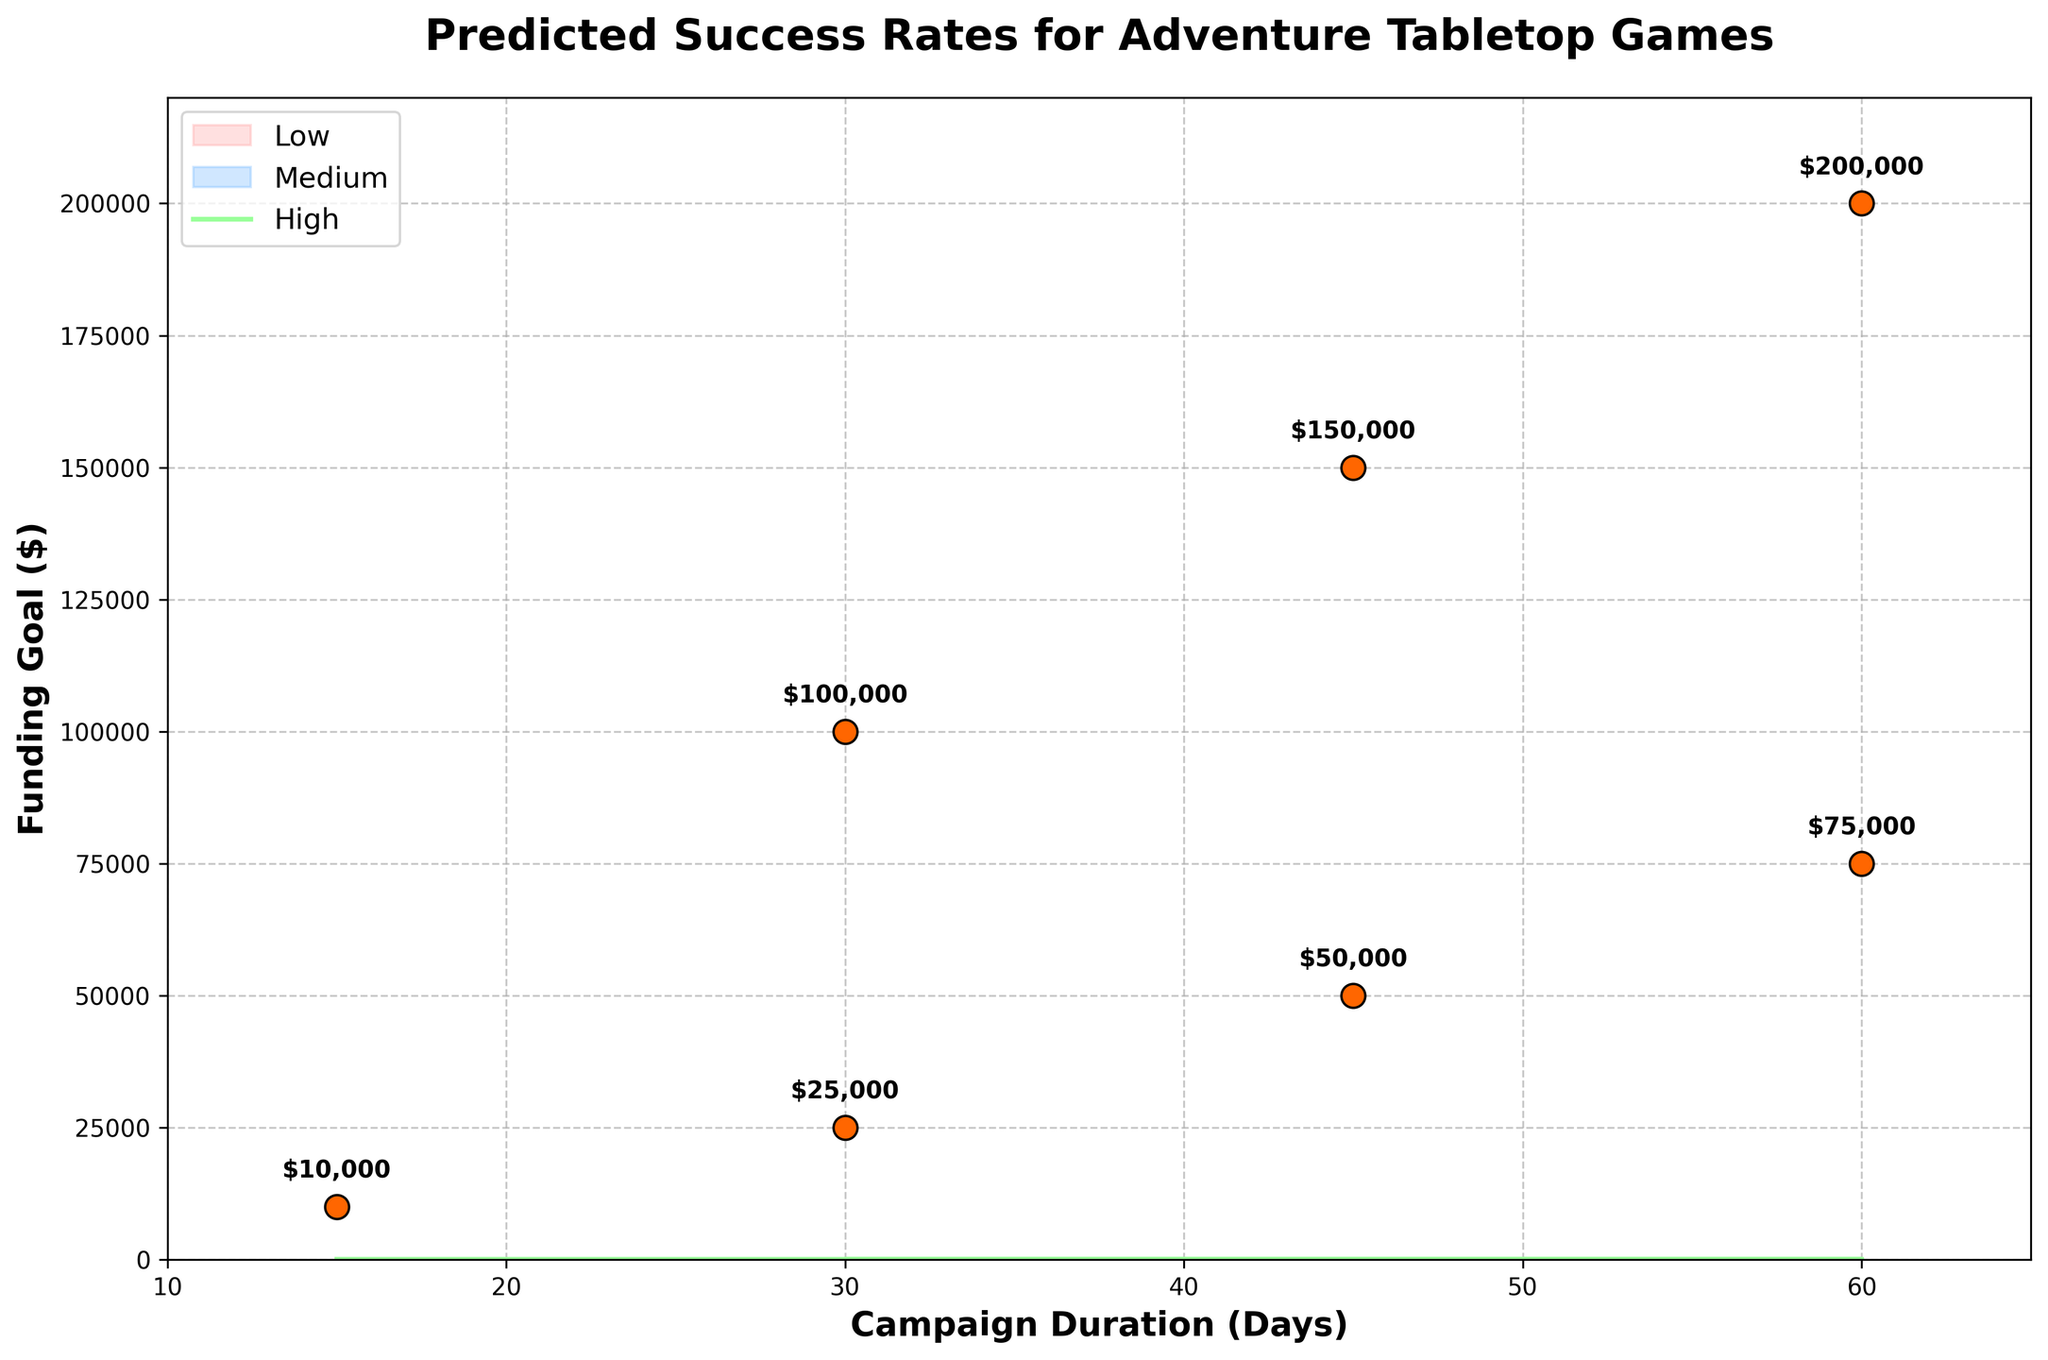What's the title of the figure? The answer can be found by simply looking at the top of the figure.
Answer: Predicted Success Rates for Adventure Tabletop Games What is the campaign duration range shown on the x-axis? The x-axis shows the range of Campaign Duration in days, and by looking at both ends of the x-axis, we can determine the range. The axis starts at 10 and ends at 65.
Answer: 10 to 65 days What color represents the 'Medium Success Rate' area in the fan chart? The Medium Success Rate area is filled with a distinct color that stands out in the legend. By checking the legend, '#66B2FF' or 'Medium' is the relevant color.
Answer: Blue How many data points are plotted as scatter points? Each data point is marked with a scatter point on the chart. By counting the individual points scattered on the plot, we see there are seven.
Answer: 7 What is the funding goal for a 45-day campaign? Look along the x-axis for a campaign duration of 45 days, then check the annotated value nearby the corresponding scatter point. It is clearly indicated as $50,000.
Answer: $50,000 What is the range of predicted success rates for a 45-day campaign with a $50,000 goal? Locate the 45-day point on the x-axis and examine the fan chart bands around this point. The low success rate is 35%, and the high success rate is 65%.
Answer: 35% to 65% What is the greatest funding goal among the campaigns, and what is its corresponding campaign duration? Look for the highest value annotated on the scatter plot which represents the funding goal. It is $200,000 and corresponds to a 60-day duration.
Answer: $200,000 for 60 days Which campaign duration has a low success rate of 25%? Identify the position where the low success rate of 25% intersects any campaign duration. This occurs at the 30-day campaign as shown in the fan chart.
Answer: 30 days Compare the high success rates of campaigns with funding goals of $10,000 and $100,000. Find the scatter points for funding goals of $10,000 and $100,000 along the x-axis and note their respective high success rates. They are 75% for $10,000 and 55% for $100,000.
Answer: 75% for $10,000 and 55% for $100,000 What is the difference in the median success rates between campaigns of 15 days and 60 days? Determine the median success rates for both campaign durations by locating their points and comparing. The median success rate for 15 days is 60%, and for 60 days, it's 30%. The difference is calculated as 60% - 30%.
Answer: 30% 